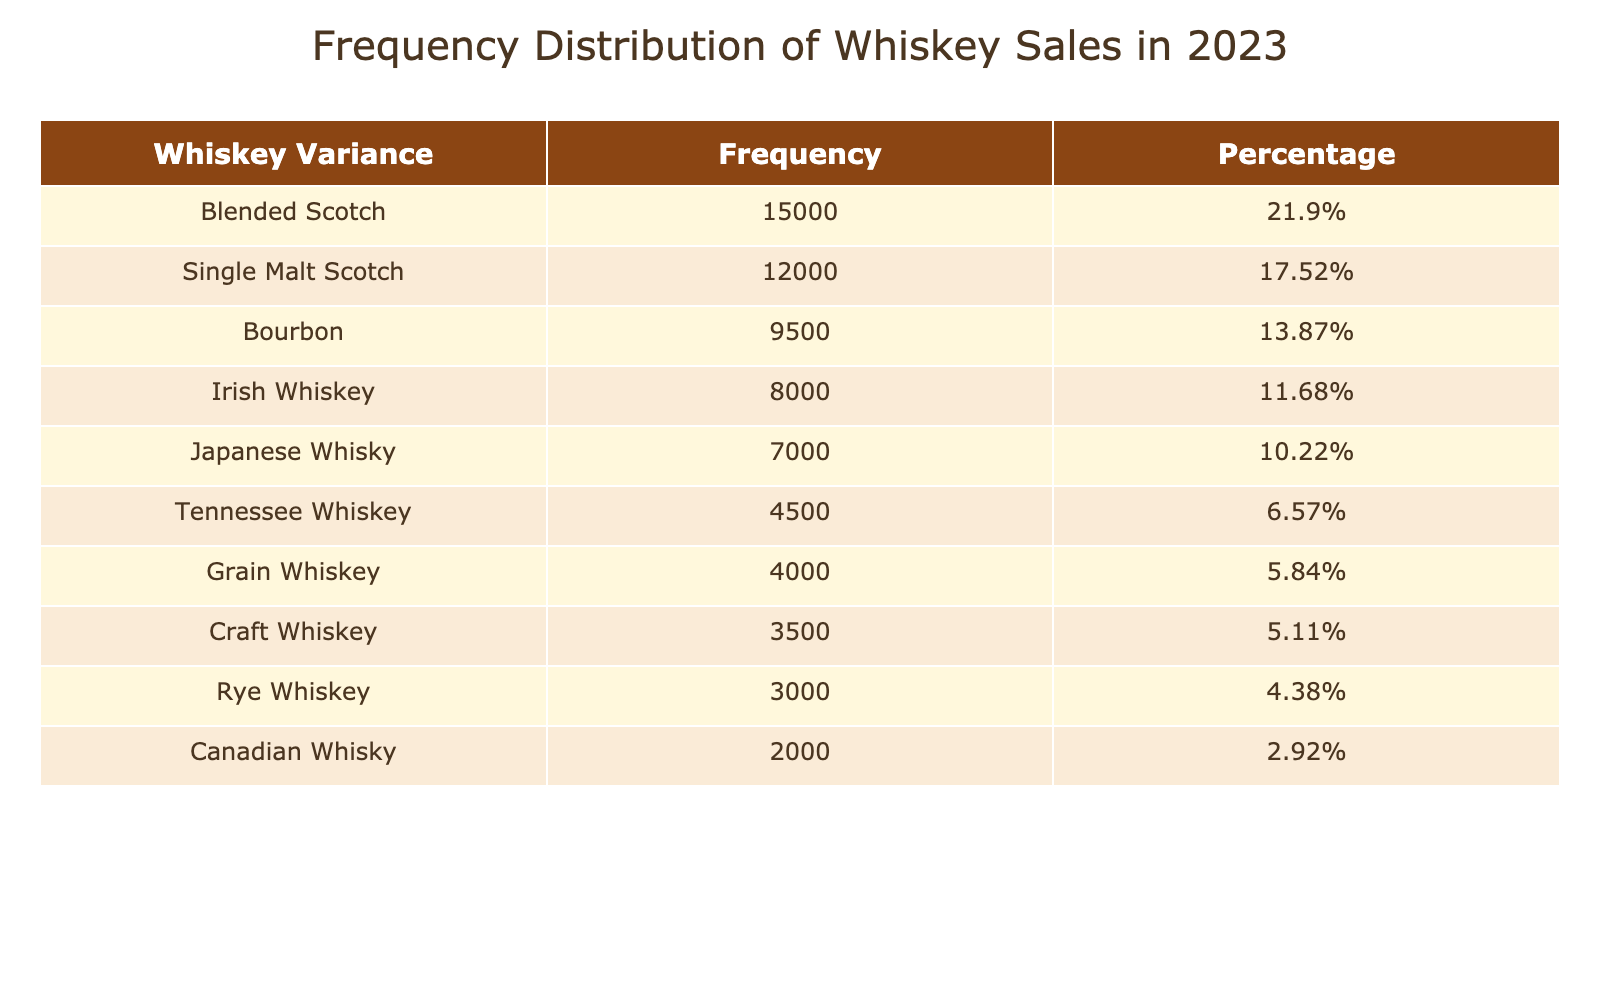What is the sales volume for Blended Scotch? The table lists the sales volume for each whiskey variance under the 'Sales Volume' column. For Blended Scotch, it shows a sales volume of 15000.
Answer: 15000 Which whiskey variance had the least sales volume? By comparing the sales volumes listed for each whiskey variance, Canadian Whisky has the least sales volume, which is 2000.
Answer: Canadian Whisky What percentage of total sales volume does Single Malt Scotch represent? First, calculate the total sales volume by adding up all the volumes: 12000 + 15000 + 8000 + 9500 + 3000 + 7000 + 2000 + 4500 + 3500 + 4000 =  50000. Single Malt Scotch sales volume is 12000, so its percentage is (12000/50000) * 100 = 24%.
Answer: 24% Is the sales volume of Rye Whiskey greater than that of Grain Whiskey? Rye Whiskey has a sales volume of 3000, while Grain Whiskey has 4000. Since 3000 is less than 4000, the statement is false.
Answer: No What is the combined sales volume of Japanese Whisky and Tennessee Whiskey? The sales volume for Japanese Whisky is 7000 and for Tennessee Whiskey it is 4500. Adding these two gives 7000 + 4500 = 11500.
Answer: 11500 Which type of whiskey accounts for more than 15% of the total sales volume? As previously found, the total sales volume is 50000. A percentage greater than 15% would correspond to a sales volume of over 7500. When checking, Blended Scotch (15000) and Single Malt Scotch (12000) both exceed this threshold.
Answer: Blended Scotch and Single Malt Scotch What is the difference in sales volume between Bourbons and Irish Whiskey? The sales volume for Bourbon is 9500, and for Irish Whiskey, it is 8000. The difference can be calculated as 9500 - 8000 = 1500.
Answer: 1500 Which whiskey type had sales that were approximately one-fifth of the total volume? Calculating one-fifth of the total sales volume (50000): 50000 / 5 = 10000. The only whiskey type close is Bourbon, with a sales volume of 9500, which is the closest to one-fifth but does not exactly equal it.
Answer: None Which whiskey varieties have combined sales that exceed 20000? First, identify whiskey types with substantial volumes: Blended Scotch (15000) + Single Malt Scotch (12000) + Bourbons (9500). The top two, Blended Scotch and Single Malt Scotch together sum to 27000, which exceeds 20000.
Answer: Blended Scotch and Single Malt Scotch 